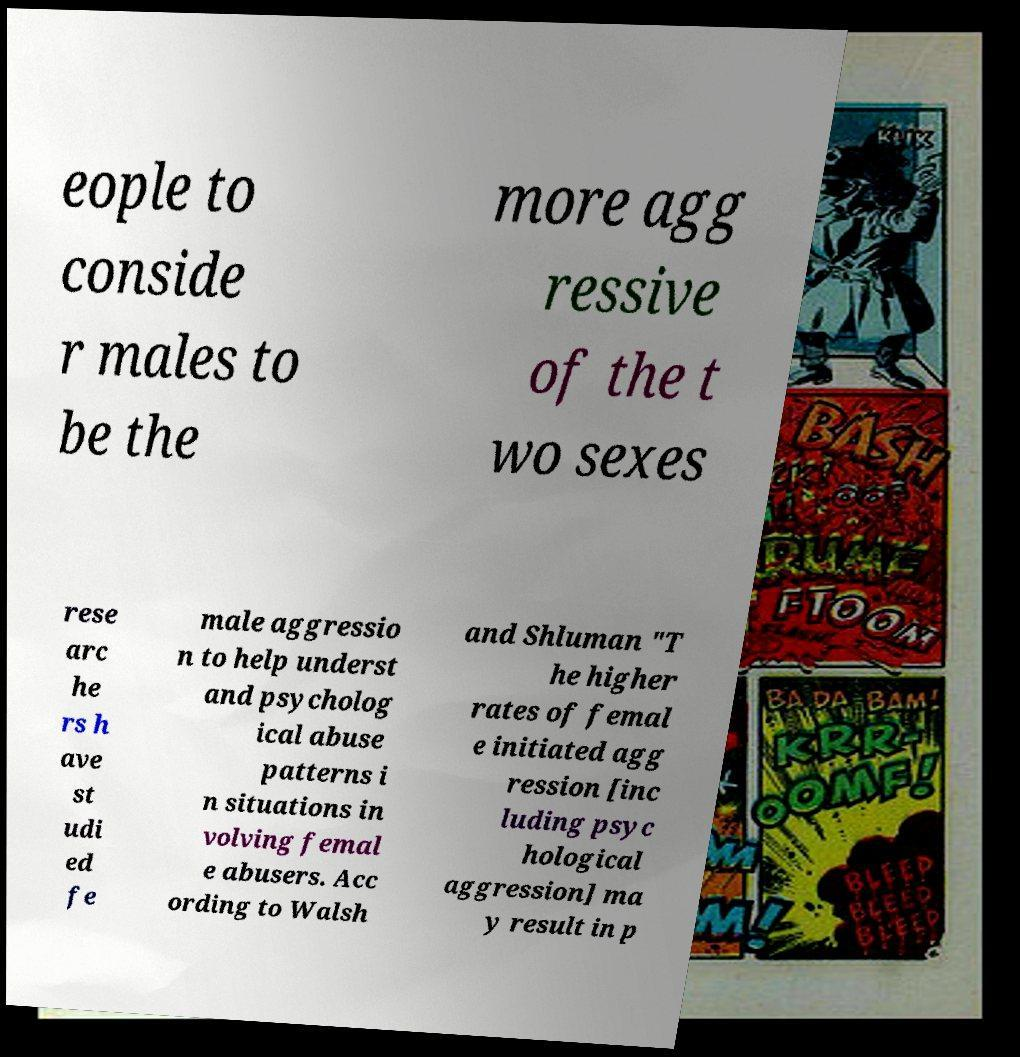What messages or text are displayed in this image? I need them in a readable, typed format. eople to conside r males to be the more agg ressive of the t wo sexes rese arc he rs h ave st udi ed fe male aggressio n to help underst and psycholog ical abuse patterns i n situations in volving femal e abusers. Acc ording to Walsh and Shluman "T he higher rates of femal e initiated agg ression [inc luding psyc hological aggression] ma y result in p 